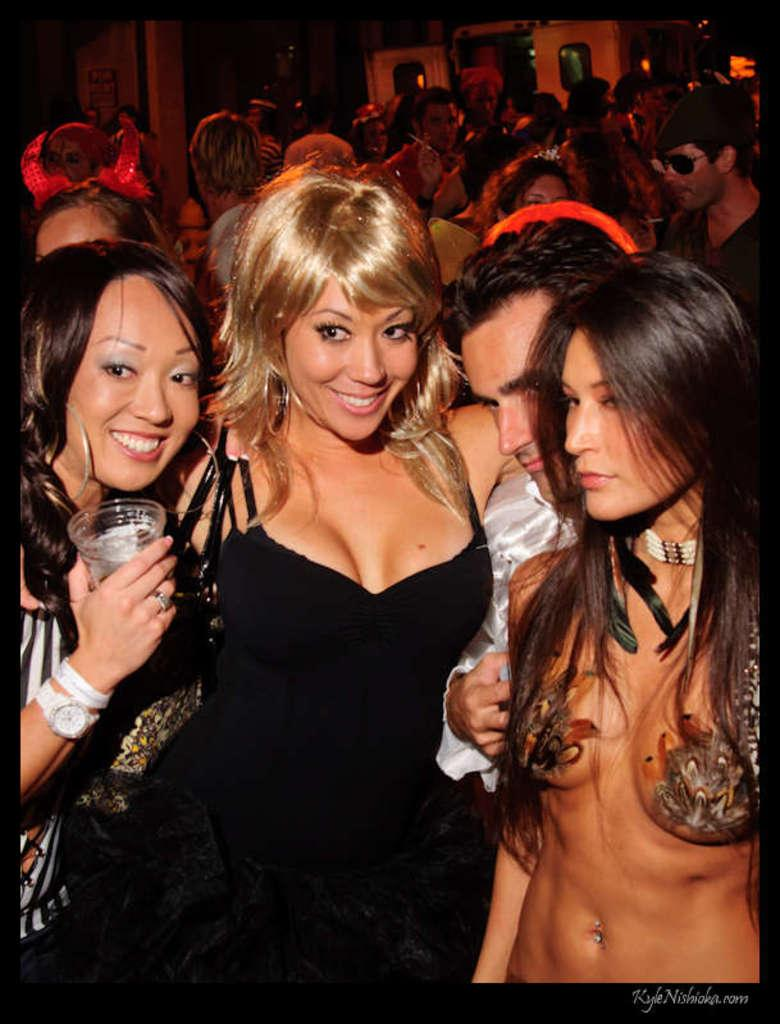Who or what can be seen in the image? There are people in the image. What is the background of the image? There is a wall in the image. Are there any openings in the wall? Yes, there are doors in the image. Is there any text visible in the image? Yes, there is text written in the bottom right corner of the image. What type of toothbrush is being used by the people in the image? There is no toothbrush present in the image. 